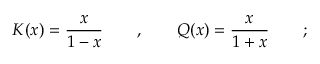Convert formula to latex. <formula><loc_0><loc_0><loc_500><loc_500>K ( x ) = \frac { x } { 1 - x } \quad , \quad Q ( x ) = \frac { x } { 1 + x } \quad ;</formula> 